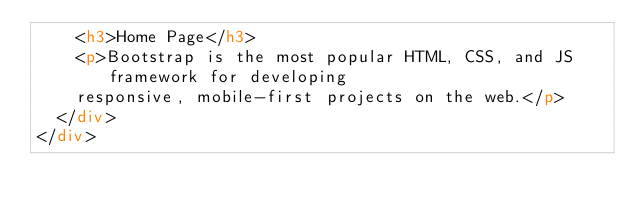<code> <loc_0><loc_0><loc_500><loc_500><_HTML_>    <h3>Home Page</h3> 
    <p>Bootstrap is the most popular HTML, CSS, and JS framework for developing
    responsive, mobile-first projects on the web.</p> 
  </div>
</div>
</code> 